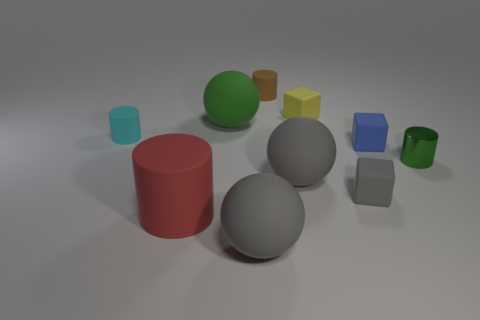Subtract all tiny green cylinders. How many cylinders are left? 3 Subtract all green cylinders. How many cylinders are left? 3 Subtract all gray cylinders. Subtract all gray blocks. How many cylinders are left? 4 Subtract all cubes. How many objects are left? 7 Subtract 0 purple cylinders. How many objects are left? 10 Subtract all big cylinders. Subtract all large spheres. How many objects are left? 6 Add 8 green rubber objects. How many green rubber objects are left? 9 Add 6 cylinders. How many cylinders exist? 10 